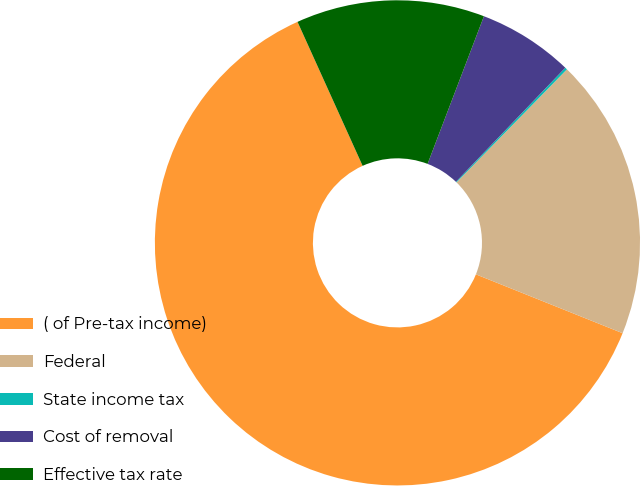Convert chart. <chart><loc_0><loc_0><loc_500><loc_500><pie_chart><fcel>( of Pre-tax income)<fcel>Federal<fcel>State income tax<fcel>Cost of removal<fcel>Effective tax rate<nl><fcel>62.17%<fcel>18.76%<fcel>0.15%<fcel>6.36%<fcel>12.56%<nl></chart> 